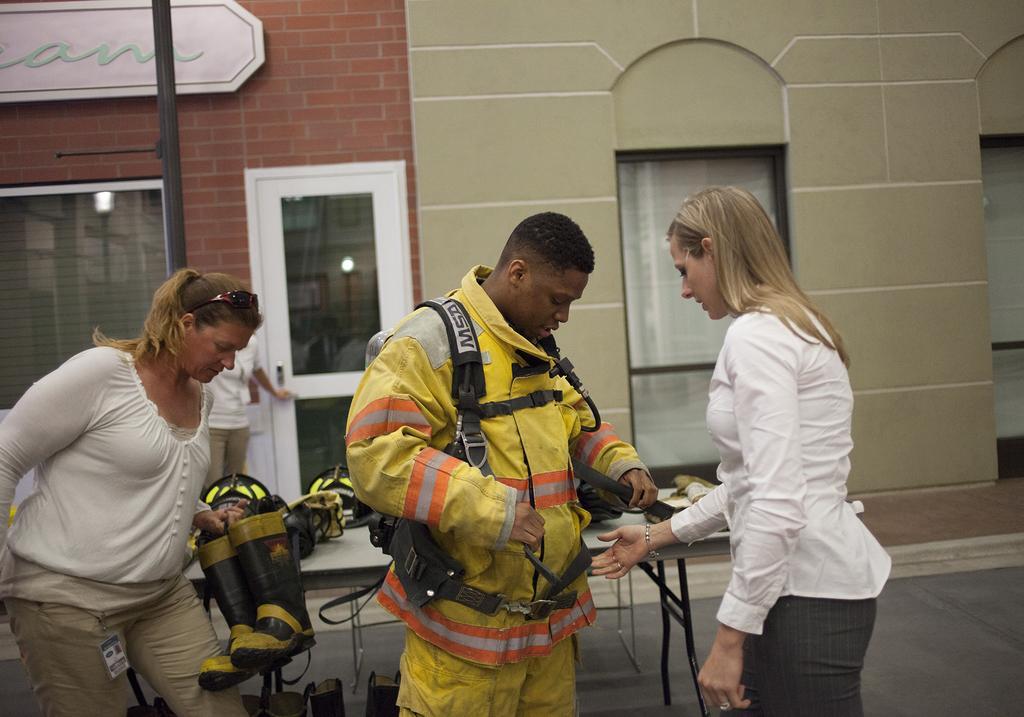In one or two sentences, can you explain what this image depicts? In the center of the image, we can see people standing and one of them is wearing safety suit and there is an another person holding shoes. In the background, we can see a pole and a building. At the bottom, there is road. 